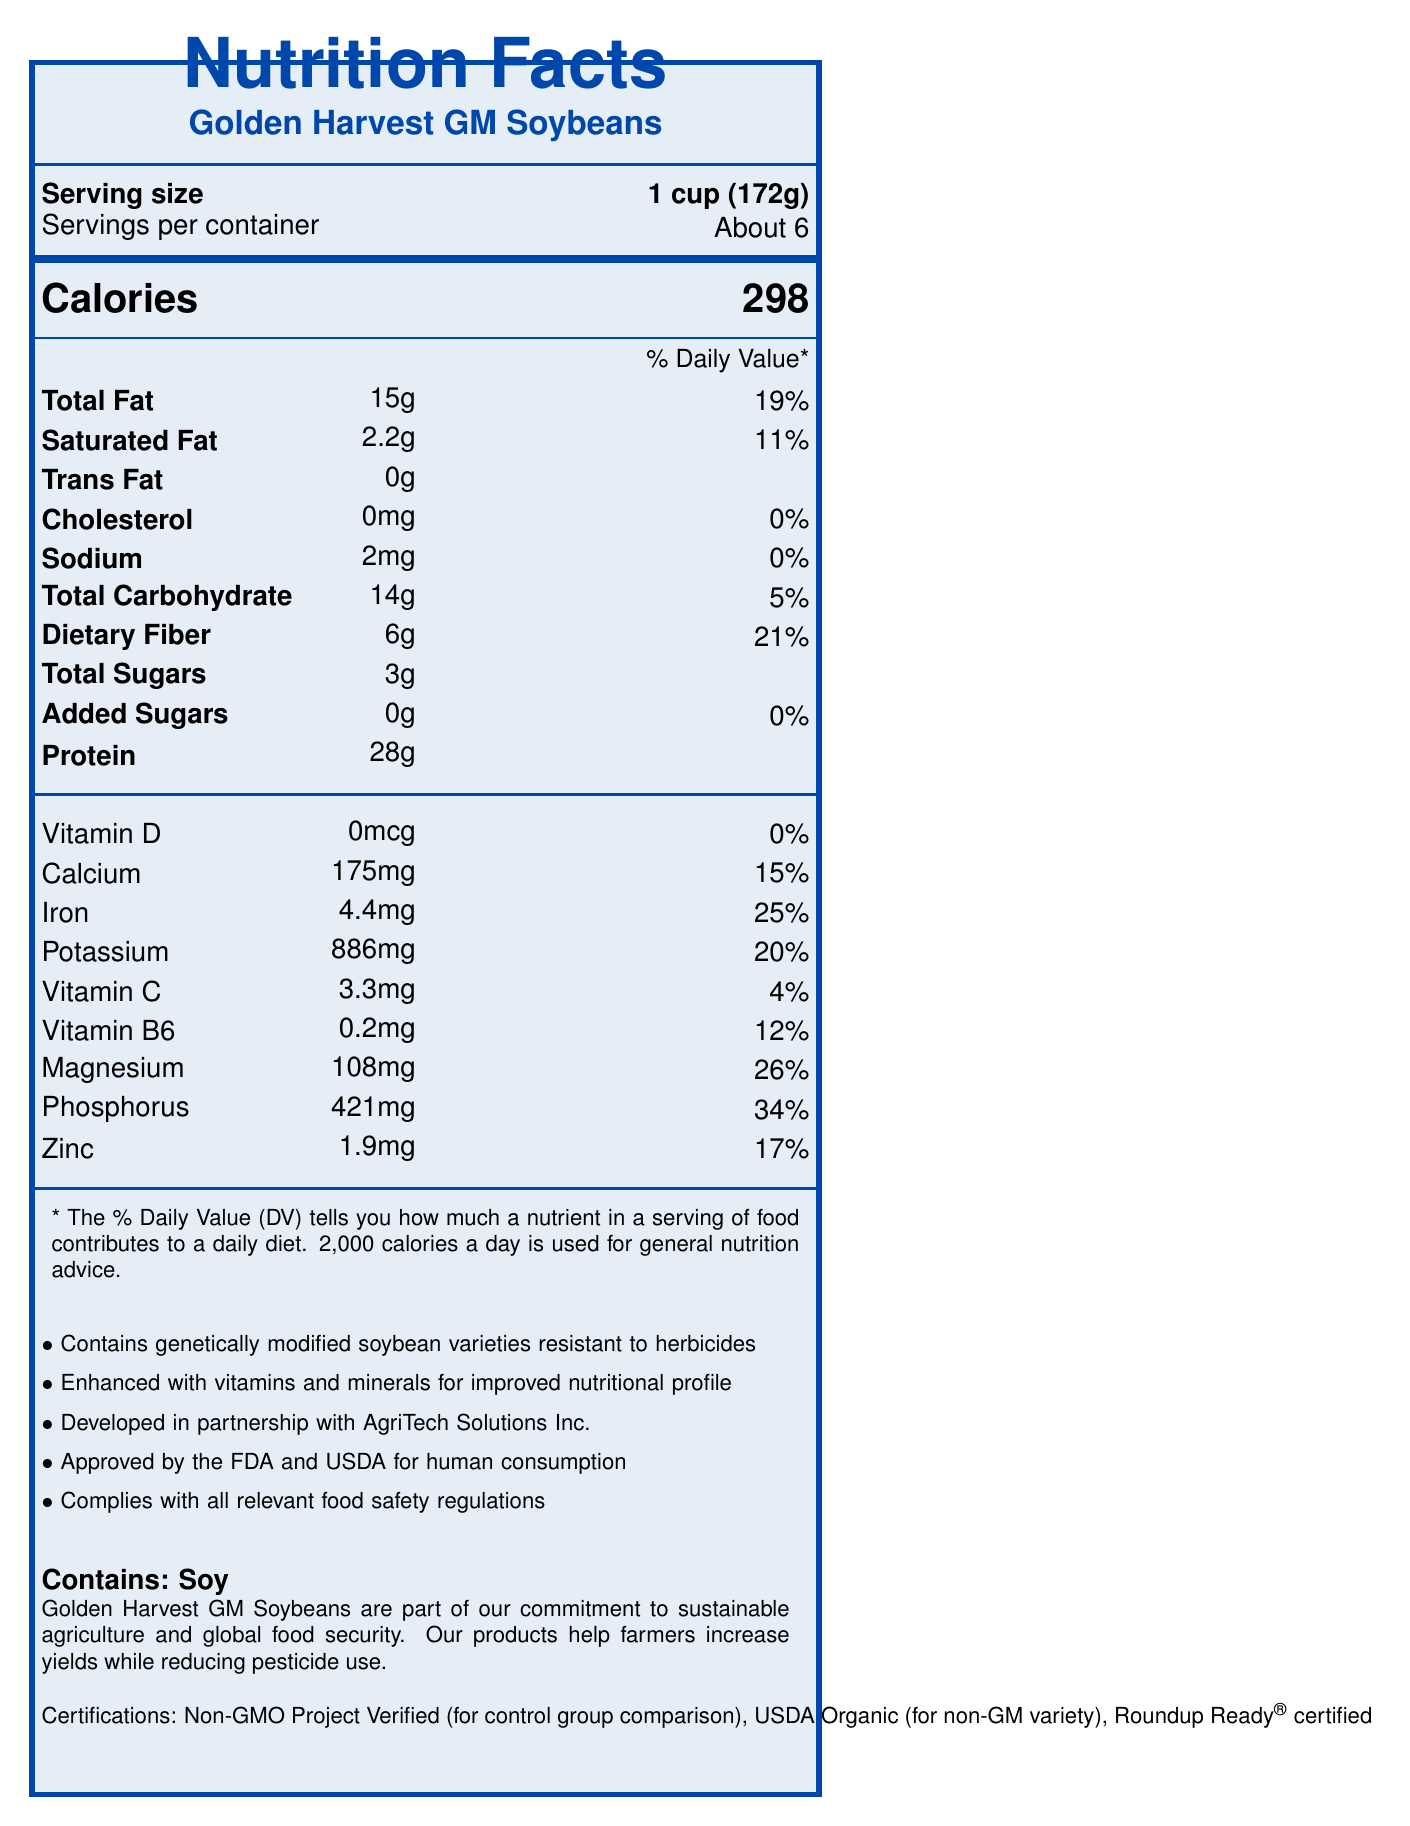what is the serving size of Golden Harvest GM Soybeans? The serving size is explicitly mentioned in the document as "1 cup (172g)".
Answer: 1 cup (172g) how many calories are in one serving? The calories per serving are listed as "298" in the document.
Answer: 298 what percentage of the daily value for iron does one serving provide? The document states that one serving provides 4.4mg of iron, which is 25% of the daily value.
Answer: 25% what is the total fat content per serving? The document lists the total fat content as "15g" per serving.
Answer: 15g does the product contain any cholesterol? The cholesterol amount is listed as "0mg", with a daily value of "0%", indicating no cholesterol content.
Answer: No how much dietary fiber is in one serving? The dietary fiber content is listed as "6g" per serving.
Answer: 6g how many servings are there per container? A. About 4 B. About 6 C. About 8 The document states "Servings per container: About 6".
Answer: B what is the percentage daily value of magnesium in a serving? The magnesium content is stated as "108mg", which is 26% of the daily value.
Answer: 26% are the Golden Harvest GM Soybeans approved by FDA and USDA for human consumption? The document states they are approved by the FDA and USDA for human consumption.
Answer: Yes does the product contain any added sugars? The amount of added sugars is listed as "0g", with a daily value of "0%".
Answer: No which certification stands out as contradictory to the product's nature? A. Non-GMO Project Verified B. USDA Organic C. Roundup Ready® certified "Non-GMO Project Verified" is contradictory since the product is genetically modified, as stated in the additional information.
Answer: A how many grams of protein does one serving contain? The document lists the protein content as "28g per serving."
Answer: 28g is the product compliant with relevant food safety regulations? The document states that the product complies with all relevant food safety regulations.
Answer: Yes describe the main idea of the document. The document is a comprehensive nutrition facts label. It outlines the nutrient content of Golden Harvest GM Soybeans, provides additional details about the product's genetic modifications, regulatory approvals, and certifications, and ends with a corporate statement promoting sustainable agriculture.
Answer: The document provides the nutrition facts label for Golden Harvest GM Soybeans, detailing serving size, calories, and nutrient content including fats, cholesterol, sodium, carbohydrates, and various vitamins and minerals. It includes additional information about genetic modifications, regulatory approvals, and certifications, plus a company statement on sustainability and food security. why was this product developed? The document does not provide specific reasons for the development of Golden Harvest GM Soybeans.
Answer: Not enough information 